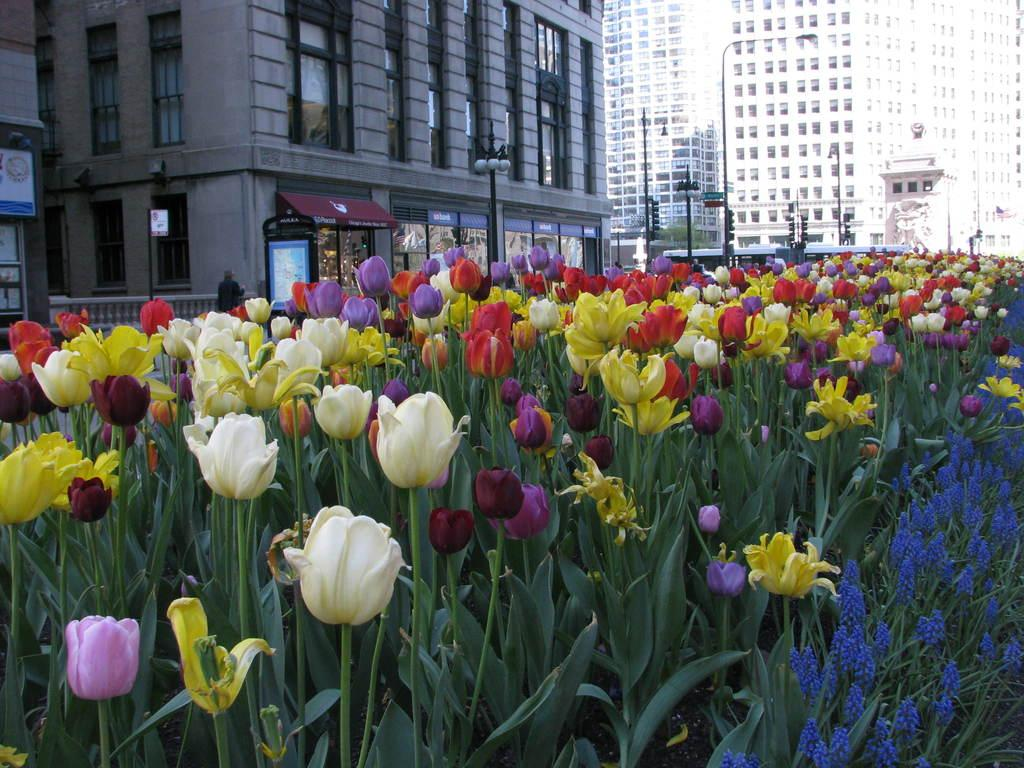What type of plants can be seen in the image? There are plants in the image, and they have colorful tulips and hyacinths. What can be seen in the background of the image? In the background, there are poles, lights, and buildings. What is the purpose of the poles in the background? The purpose of the poles in the background is not specified in the image, but they could be for supporting lights or other structures. What type of action is the rat performing in the image? There is no rat present in the image, so it is not possible to answer that question. 